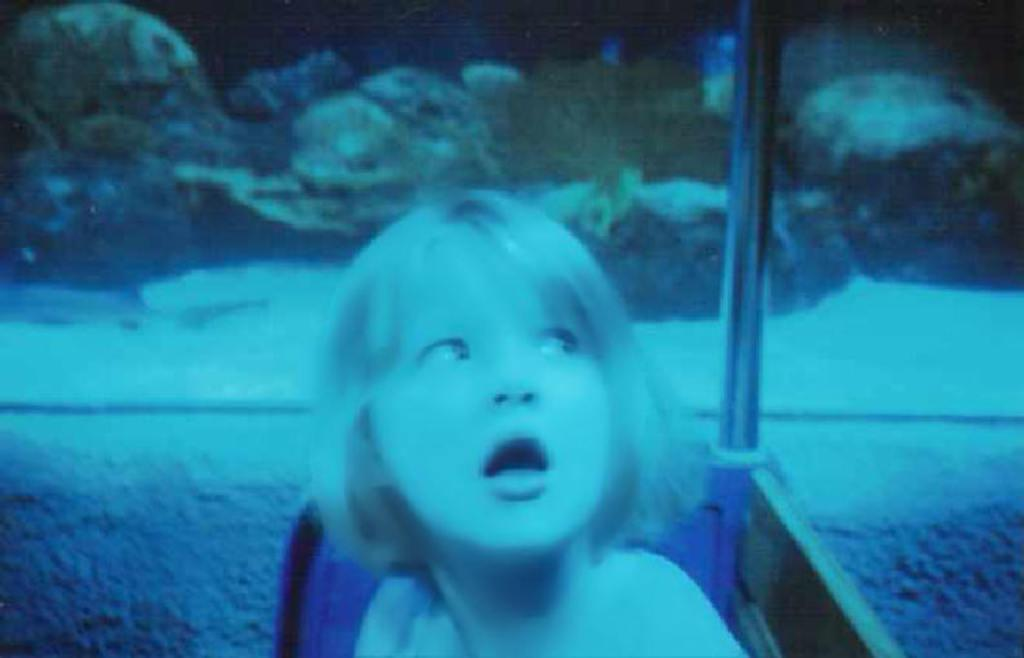Who is present in the image? There is a girl in the image. What object can be seen in the image? There is a pole in the image. What can be seen in the background of the image? Water and rocks are visible in the background of the image. How do the girl's eyes help her see in the image? The image does not show the girl's eyes, so we cannot determine how they help her see. 